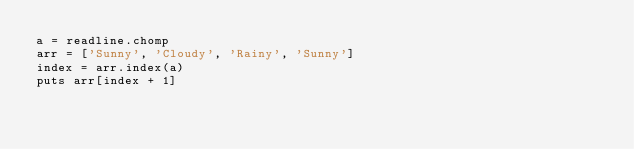Convert code to text. <code><loc_0><loc_0><loc_500><loc_500><_Ruby_>a = readline.chomp
arr = ['Sunny', 'Cloudy', 'Rainy', 'Sunny']
index = arr.index(a)
puts arr[index + 1]</code> 